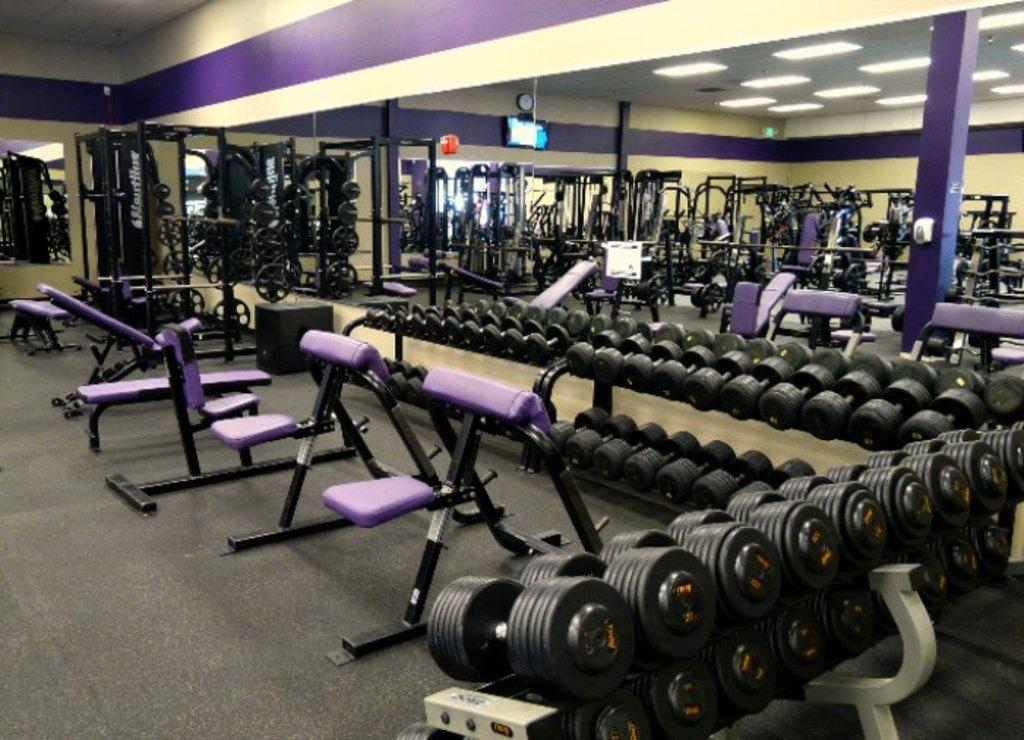What type of equipment can be seen in the image? There are dumbbells and other exercise equipment in the image. What is visible on the floor in the image? Exercise equipment is visible on the floor in the image. What can be seen in the background of the image? There are lights, walls, pillars, a screen, a clock, and some objects in the background of the image. What type of plants can be seen growing on the dumbbells in the image? There are no plants visible on the dumbbells in the image. 